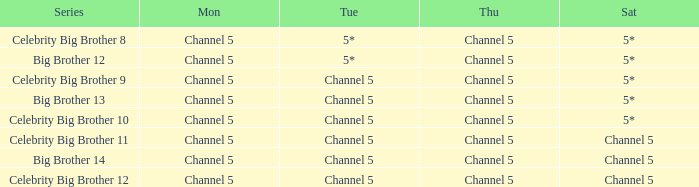Which Thursday does big brother 13 air? Channel 5. 